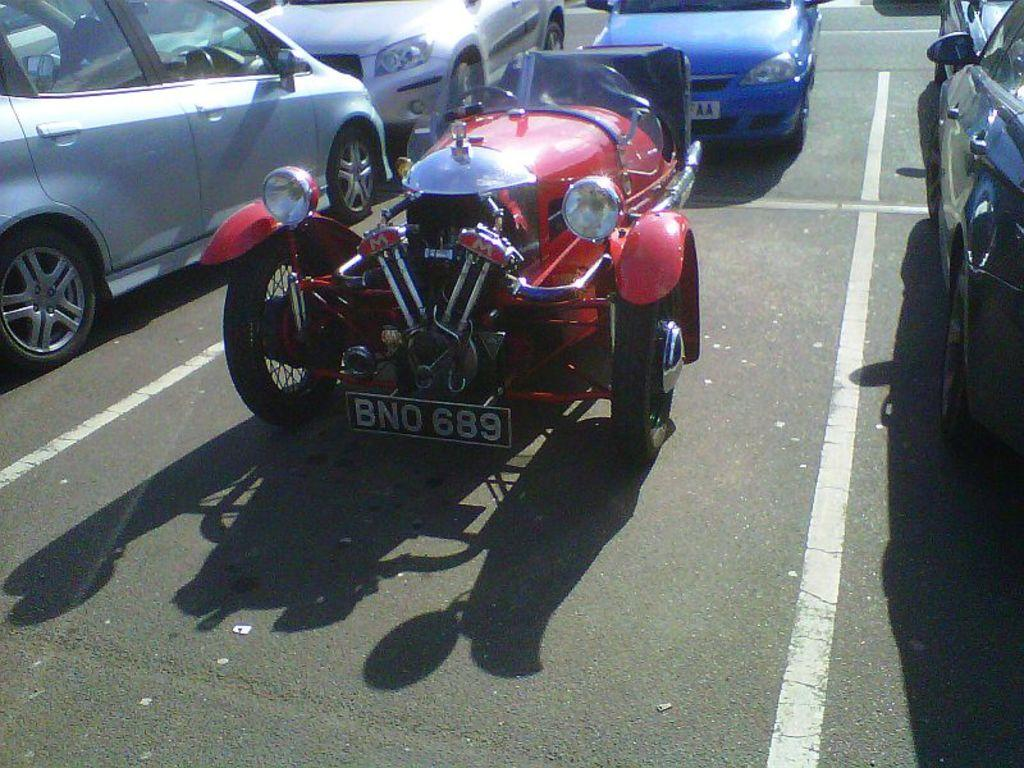What types of objects are present in the image? There are vehicles in the image. Can you describe the appearance of the vehicles? The vehicles are of different colors. Where are the vehicles located? The vehicles are on the road. How are the vehicles positioned in the image? The vehicles are in the center of the image. How many bears can be seen holding a nail in the image? There are no bears or nails present in the image; it features vehicles on the road. 